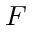<formula> <loc_0><loc_0><loc_500><loc_500>F</formula> 